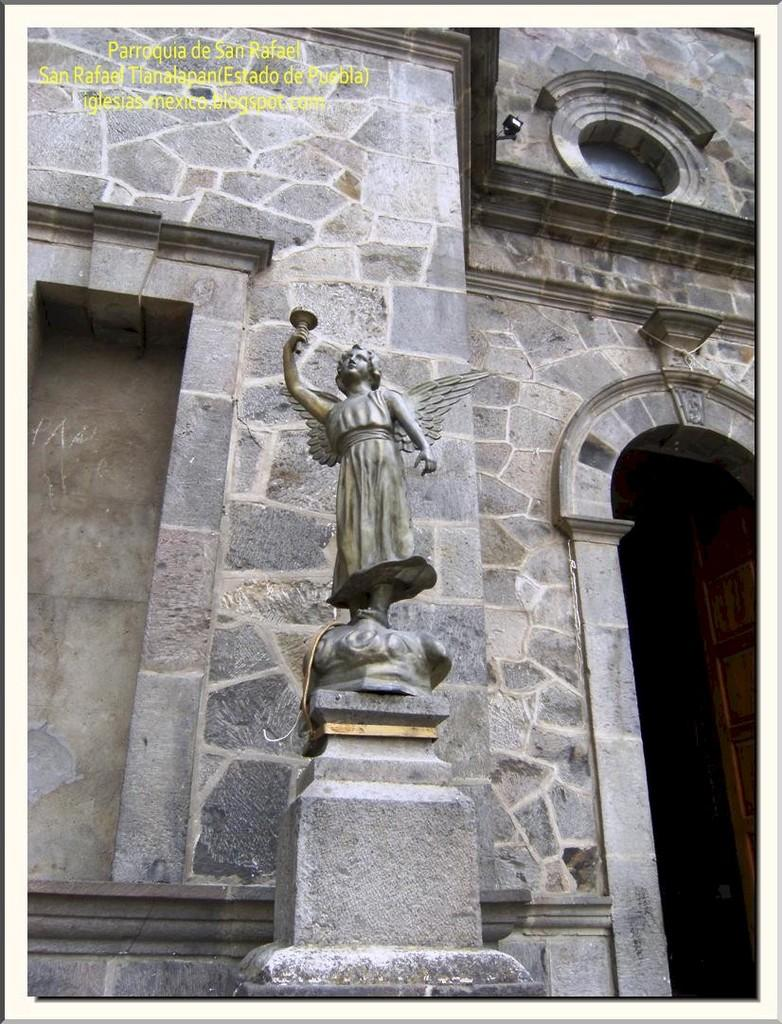What is the main subject on the platform in the image? There is a statue on a platform in the image. What type of structure can be seen in the image? There is a wall in the image. Is there any entrance visible in the image? Yes, there is a door in the image. What architectural feature is present in the image? There is an arch in the image. Where can some text be found in the image? Some text is visible in the top left corner of the image. How many rings are being worn by the statue in the image? There are no rings visible on the statue in the image. What type of glass is used to create the statue in the image? The statue is not made of glass; it is a solid structure. 